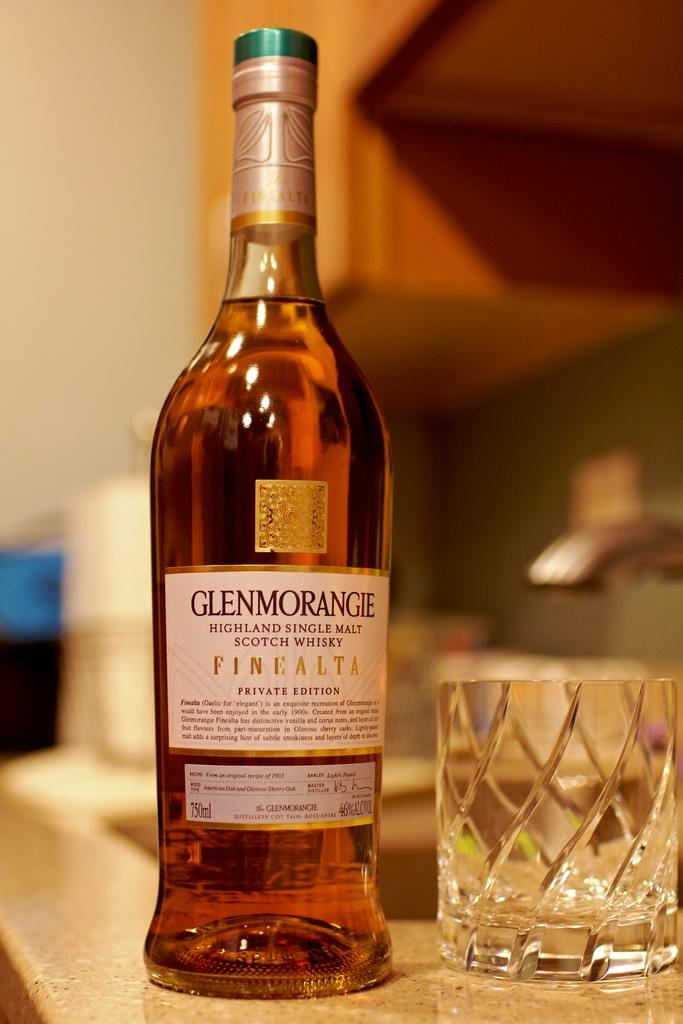What piece of furniture is present in the image? There is a table in the image. What objects are on the table? There is a bottle and a glass on the table. What is unique about the bottle? The bottle has stickers on it. What can be seen in the background of the image? There is a sink with a tap and a wall in the background. What decision is being made by the cattle in the image? There are no cattle present in the image, so no decision can be made by them. What journey is depicted in the image? There is no journey depicted in the image; it features a table with a bottle and a glass, along with a sink and a wall in the background. 